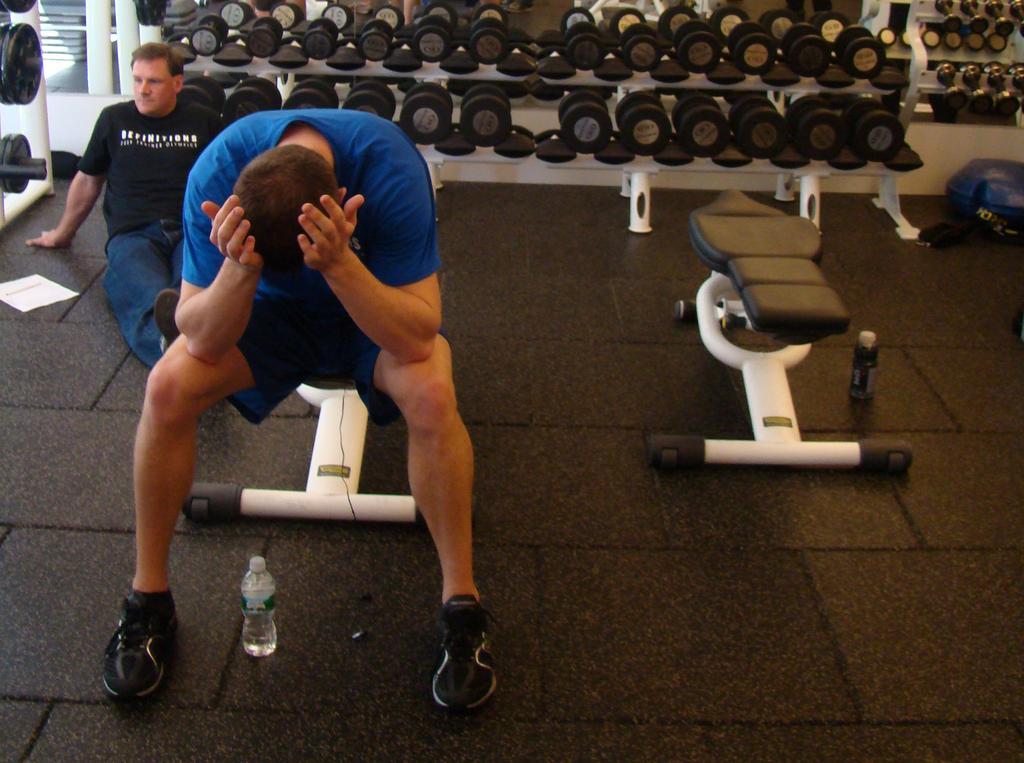In one or two sentences, can you explain what this image depicts? On the left side, there is a person in a blue color t-shirt, keeping both hands on his head, keeping both elbows on his legs and sitting on a furniture of a gym. Beside him, there is a bottle on the floor and a person in a black color t-shirt, sitting. Beside him, there is a paper on the floor. On the right side, there is a furniture of the gym. Beside this furniture, there is a bottle on the floor. In the background, there are gym furniture arranged. 